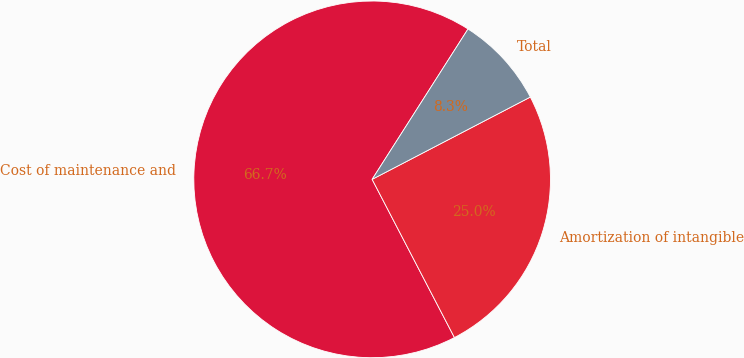Convert chart to OTSL. <chart><loc_0><loc_0><loc_500><loc_500><pie_chart><fcel>Cost of maintenance and<fcel>Amortization of intangible<fcel>Total<nl><fcel>66.67%<fcel>25.0%<fcel>8.33%<nl></chart> 